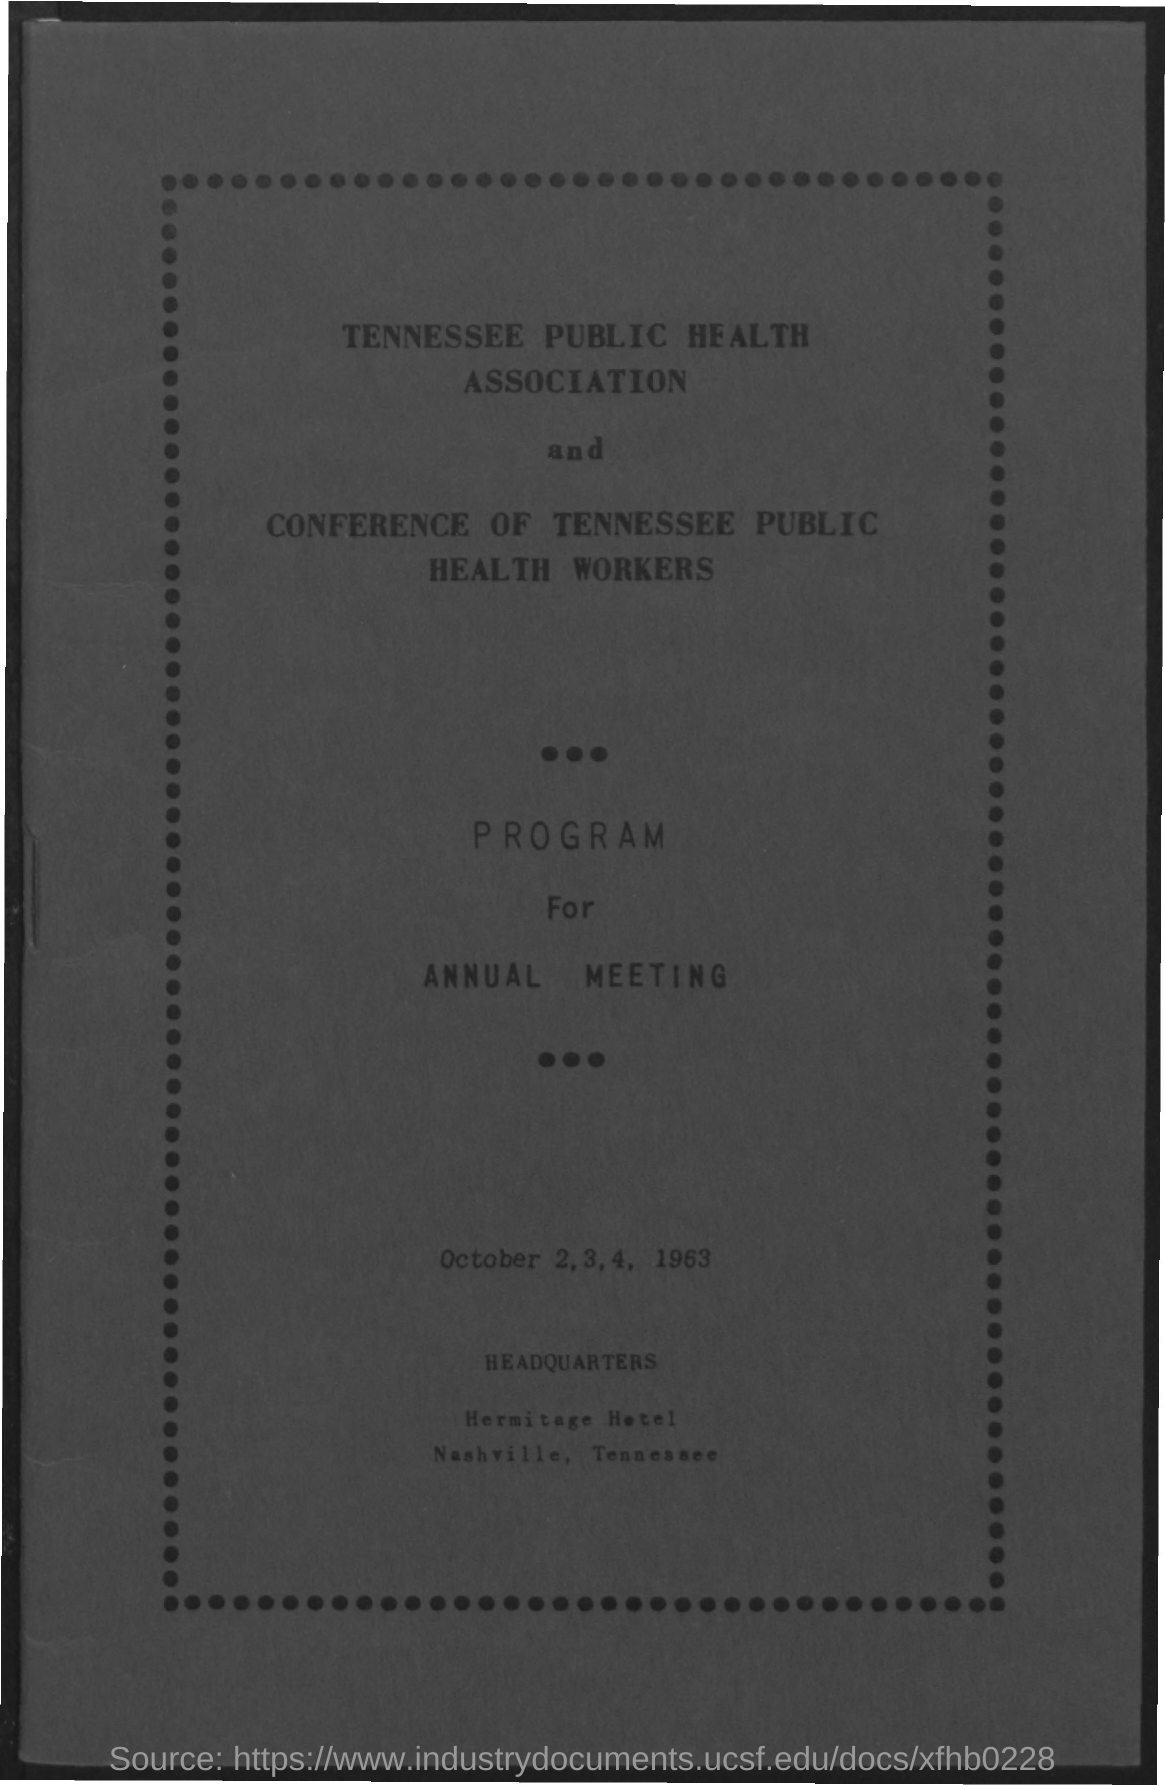Mention a couple of crucial points in this snapshot. The name of the association mentioned in the given form is the Tennessee Public Health Association. The hotel mentioned is named the Hermitage Hotel. The dates mentioned in the given page are October 2, 3, 4, and 1963. 